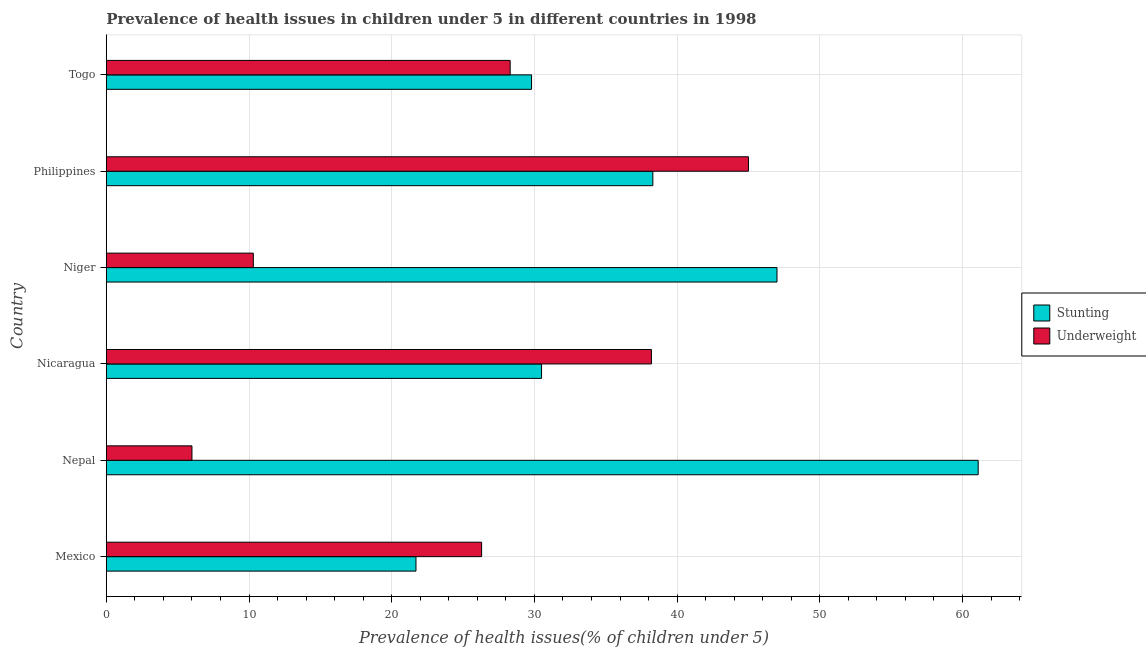How many different coloured bars are there?
Keep it short and to the point. 2. How many groups of bars are there?
Offer a terse response. 6. Are the number of bars per tick equal to the number of legend labels?
Offer a terse response. Yes. Are the number of bars on each tick of the Y-axis equal?
Offer a very short reply. Yes. How many bars are there on the 1st tick from the bottom?
Your response must be concise. 2. What is the percentage of underweight children in Nepal?
Ensure brevity in your answer.  6. Across all countries, what is the maximum percentage of underweight children?
Offer a very short reply. 45. Across all countries, what is the minimum percentage of underweight children?
Your response must be concise. 6. In which country was the percentage of stunted children maximum?
Give a very brief answer. Nepal. What is the total percentage of stunted children in the graph?
Your answer should be compact. 228.4. What is the difference between the percentage of stunted children in Niger and the percentage of underweight children in Nepal?
Give a very brief answer. 41. What is the average percentage of stunted children per country?
Provide a succinct answer. 38.07. What is the difference between the percentage of stunted children and percentage of underweight children in Mexico?
Keep it short and to the point. -4.6. In how many countries, is the percentage of underweight children greater than 32 %?
Offer a very short reply. 2. What is the ratio of the percentage of underweight children in Mexico to that in Philippines?
Your answer should be very brief. 0.58. Is the difference between the percentage of underweight children in Nicaragua and Philippines greater than the difference between the percentage of stunted children in Nicaragua and Philippines?
Offer a terse response. Yes. What is the difference between the highest and the lowest percentage of stunted children?
Keep it short and to the point. 39.4. In how many countries, is the percentage of stunted children greater than the average percentage of stunted children taken over all countries?
Give a very brief answer. 3. Is the sum of the percentage of underweight children in Nepal and Philippines greater than the maximum percentage of stunted children across all countries?
Make the answer very short. No. What does the 1st bar from the top in Togo represents?
Your answer should be compact. Underweight. What does the 1st bar from the bottom in Togo represents?
Provide a short and direct response. Stunting. How many countries are there in the graph?
Ensure brevity in your answer.  6. What is the difference between two consecutive major ticks on the X-axis?
Offer a terse response. 10. Are the values on the major ticks of X-axis written in scientific E-notation?
Give a very brief answer. No. Does the graph contain grids?
Offer a very short reply. Yes. Where does the legend appear in the graph?
Give a very brief answer. Center right. How are the legend labels stacked?
Your answer should be compact. Vertical. What is the title of the graph?
Make the answer very short. Prevalence of health issues in children under 5 in different countries in 1998. What is the label or title of the X-axis?
Ensure brevity in your answer.  Prevalence of health issues(% of children under 5). What is the Prevalence of health issues(% of children under 5) of Stunting in Mexico?
Your answer should be very brief. 21.7. What is the Prevalence of health issues(% of children under 5) of Underweight in Mexico?
Your answer should be compact. 26.3. What is the Prevalence of health issues(% of children under 5) of Stunting in Nepal?
Keep it short and to the point. 61.1. What is the Prevalence of health issues(% of children under 5) in Stunting in Nicaragua?
Your answer should be compact. 30.5. What is the Prevalence of health issues(% of children under 5) in Underweight in Nicaragua?
Offer a terse response. 38.2. What is the Prevalence of health issues(% of children under 5) in Stunting in Niger?
Give a very brief answer. 47. What is the Prevalence of health issues(% of children under 5) of Underweight in Niger?
Offer a terse response. 10.3. What is the Prevalence of health issues(% of children under 5) in Stunting in Philippines?
Your answer should be compact. 38.3. What is the Prevalence of health issues(% of children under 5) of Underweight in Philippines?
Offer a terse response. 45. What is the Prevalence of health issues(% of children under 5) in Stunting in Togo?
Your answer should be very brief. 29.8. What is the Prevalence of health issues(% of children under 5) in Underweight in Togo?
Keep it short and to the point. 28.3. Across all countries, what is the maximum Prevalence of health issues(% of children under 5) of Stunting?
Your response must be concise. 61.1. Across all countries, what is the maximum Prevalence of health issues(% of children under 5) in Underweight?
Give a very brief answer. 45. Across all countries, what is the minimum Prevalence of health issues(% of children under 5) in Stunting?
Your answer should be compact. 21.7. What is the total Prevalence of health issues(% of children under 5) of Stunting in the graph?
Ensure brevity in your answer.  228.4. What is the total Prevalence of health issues(% of children under 5) in Underweight in the graph?
Ensure brevity in your answer.  154.1. What is the difference between the Prevalence of health issues(% of children under 5) of Stunting in Mexico and that in Nepal?
Offer a very short reply. -39.4. What is the difference between the Prevalence of health issues(% of children under 5) in Underweight in Mexico and that in Nepal?
Offer a terse response. 20.3. What is the difference between the Prevalence of health issues(% of children under 5) of Stunting in Mexico and that in Niger?
Ensure brevity in your answer.  -25.3. What is the difference between the Prevalence of health issues(% of children under 5) of Stunting in Mexico and that in Philippines?
Keep it short and to the point. -16.6. What is the difference between the Prevalence of health issues(% of children under 5) in Underweight in Mexico and that in Philippines?
Offer a very short reply. -18.7. What is the difference between the Prevalence of health issues(% of children under 5) of Underweight in Mexico and that in Togo?
Your response must be concise. -2. What is the difference between the Prevalence of health issues(% of children under 5) in Stunting in Nepal and that in Nicaragua?
Provide a short and direct response. 30.6. What is the difference between the Prevalence of health issues(% of children under 5) in Underweight in Nepal and that in Nicaragua?
Ensure brevity in your answer.  -32.2. What is the difference between the Prevalence of health issues(% of children under 5) of Stunting in Nepal and that in Niger?
Offer a terse response. 14.1. What is the difference between the Prevalence of health issues(% of children under 5) in Underweight in Nepal and that in Niger?
Provide a succinct answer. -4.3. What is the difference between the Prevalence of health issues(% of children under 5) in Stunting in Nepal and that in Philippines?
Offer a very short reply. 22.8. What is the difference between the Prevalence of health issues(% of children under 5) in Underweight in Nepal and that in Philippines?
Provide a succinct answer. -39. What is the difference between the Prevalence of health issues(% of children under 5) of Stunting in Nepal and that in Togo?
Your answer should be very brief. 31.3. What is the difference between the Prevalence of health issues(% of children under 5) of Underweight in Nepal and that in Togo?
Your response must be concise. -22.3. What is the difference between the Prevalence of health issues(% of children under 5) of Stunting in Nicaragua and that in Niger?
Your answer should be compact. -16.5. What is the difference between the Prevalence of health issues(% of children under 5) of Underweight in Nicaragua and that in Niger?
Keep it short and to the point. 27.9. What is the difference between the Prevalence of health issues(% of children under 5) in Underweight in Nicaragua and that in Philippines?
Make the answer very short. -6.8. What is the difference between the Prevalence of health issues(% of children under 5) of Stunting in Nicaragua and that in Togo?
Your answer should be very brief. 0.7. What is the difference between the Prevalence of health issues(% of children under 5) of Underweight in Niger and that in Philippines?
Offer a very short reply. -34.7. What is the difference between the Prevalence of health issues(% of children under 5) in Stunting in Niger and that in Togo?
Offer a very short reply. 17.2. What is the difference between the Prevalence of health issues(% of children under 5) in Underweight in Philippines and that in Togo?
Your answer should be very brief. 16.7. What is the difference between the Prevalence of health issues(% of children under 5) of Stunting in Mexico and the Prevalence of health issues(% of children under 5) of Underweight in Nepal?
Your answer should be very brief. 15.7. What is the difference between the Prevalence of health issues(% of children under 5) in Stunting in Mexico and the Prevalence of health issues(% of children under 5) in Underweight in Nicaragua?
Make the answer very short. -16.5. What is the difference between the Prevalence of health issues(% of children under 5) in Stunting in Mexico and the Prevalence of health issues(% of children under 5) in Underweight in Niger?
Provide a short and direct response. 11.4. What is the difference between the Prevalence of health issues(% of children under 5) of Stunting in Mexico and the Prevalence of health issues(% of children under 5) of Underweight in Philippines?
Ensure brevity in your answer.  -23.3. What is the difference between the Prevalence of health issues(% of children under 5) of Stunting in Mexico and the Prevalence of health issues(% of children under 5) of Underweight in Togo?
Ensure brevity in your answer.  -6.6. What is the difference between the Prevalence of health issues(% of children under 5) in Stunting in Nepal and the Prevalence of health issues(% of children under 5) in Underweight in Nicaragua?
Your answer should be very brief. 22.9. What is the difference between the Prevalence of health issues(% of children under 5) of Stunting in Nepal and the Prevalence of health issues(% of children under 5) of Underweight in Niger?
Offer a very short reply. 50.8. What is the difference between the Prevalence of health issues(% of children under 5) of Stunting in Nepal and the Prevalence of health issues(% of children under 5) of Underweight in Togo?
Keep it short and to the point. 32.8. What is the difference between the Prevalence of health issues(% of children under 5) of Stunting in Nicaragua and the Prevalence of health issues(% of children under 5) of Underweight in Niger?
Provide a succinct answer. 20.2. What is the average Prevalence of health issues(% of children under 5) of Stunting per country?
Keep it short and to the point. 38.07. What is the average Prevalence of health issues(% of children under 5) in Underweight per country?
Offer a terse response. 25.68. What is the difference between the Prevalence of health issues(% of children under 5) of Stunting and Prevalence of health issues(% of children under 5) of Underweight in Mexico?
Provide a succinct answer. -4.6. What is the difference between the Prevalence of health issues(% of children under 5) in Stunting and Prevalence of health issues(% of children under 5) in Underweight in Nepal?
Offer a very short reply. 55.1. What is the difference between the Prevalence of health issues(% of children under 5) of Stunting and Prevalence of health issues(% of children under 5) of Underweight in Niger?
Keep it short and to the point. 36.7. What is the difference between the Prevalence of health issues(% of children under 5) in Stunting and Prevalence of health issues(% of children under 5) in Underweight in Philippines?
Your answer should be very brief. -6.7. What is the difference between the Prevalence of health issues(% of children under 5) of Stunting and Prevalence of health issues(% of children under 5) of Underweight in Togo?
Give a very brief answer. 1.5. What is the ratio of the Prevalence of health issues(% of children under 5) in Stunting in Mexico to that in Nepal?
Ensure brevity in your answer.  0.36. What is the ratio of the Prevalence of health issues(% of children under 5) in Underweight in Mexico to that in Nepal?
Your answer should be compact. 4.38. What is the ratio of the Prevalence of health issues(% of children under 5) of Stunting in Mexico to that in Nicaragua?
Provide a succinct answer. 0.71. What is the ratio of the Prevalence of health issues(% of children under 5) of Underweight in Mexico to that in Nicaragua?
Ensure brevity in your answer.  0.69. What is the ratio of the Prevalence of health issues(% of children under 5) in Stunting in Mexico to that in Niger?
Your response must be concise. 0.46. What is the ratio of the Prevalence of health issues(% of children under 5) in Underweight in Mexico to that in Niger?
Provide a short and direct response. 2.55. What is the ratio of the Prevalence of health issues(% of children under 5) in Stunting in Mexico to that in Philippines?
Your answer should be very brief. 0.57. What is the ratio of the Prevalence of health issues(% of children under 5) of Underweight in Mexico to that in Philippines?
Keep it short and to the point. 0.58. What is the ratio of the Prevalence of health issues(% of children under 5) in Stunting in Mexico to that in Togo?
Provide a short and direct response. 0.73. What is the ratio of the Prevalence of health issues(% of children under 5) of Underweight in Mexico to that in Togo?
Your answer should be compact. 0.93. What is the ratio of the Prevalence of health issues(% of children under 5) in Stunting in Nepal to that in Nicaragua?
Make the answer very short. 2. What is the ratio of the Prevalence of health issues(% of children under 5) in Underweight in Nepal to that in Nicaragua?
Provide a succinct answer. 0.16. What is the ratio of the Prevalence of health issues(% of children under 5) in Stunting in Nepal to that in Niger?
Provide a short and direct response. 1.3. What is the ratio of the Prevalence of health issues(% of children under 5) of Underweight in Nepal to that in Niger?
Your answer should be very brief. 0.58. What is the ratio of the Prevalence of health issues(% of children under 5) of Stunting in Nepal to that in Philippines?
Keep it short and to the point. 1.6. What is the ratio of the Prevalence of health issues(% of children under 5) in Underweight in Nepal to that in Philippines?
Ensure brevity in your answer.  0.13. What is the ratio of the Prevalence of health issues(% of children under 5) in Stunting in Nepal to that in Togo?
Make the answer very short. 2.05. What is the ratio of the Prevalence of health issues(% of children under 5) in Underweight in Nepal to that in Togo?
Give a very brief answer. 0.21. What is the ratio of the Prevalence of health issues(% of children under 5) of Stunting in Nicaragua to that in Niger?
Offer a terse response. 0.65. What is the ratio of the Prevalence of health issues(% of children under 5) of Underweight in Nicaragua to that in Niger?
Ensure brevity in your answer.  3.71. What is the ratio of the Prevalence of health issues(% of children under 5) in Stunting in Nicaragua to that in Philippines?
Make the answer very short. 0.8. What is the ratio of the Prevalence of health issues(% of children under 5) of Underweight in Nicaragua to that in Philippines?
Offer a terse response. 0.85. What is the ratio of the Prevalence of health issues(% of children under 5) of Stunting in Nicaragua to that in Togo?
Offer a terse response. 1.02. What is the ratio of the Prevalence of health issues(% of children under 5) of Underweight in Nicaragua to that in Togo?
Ensure brevity in your answer.  1.35. What is the ratio of the Prevalence of health issues(% of children under 5) of Stunting in Niger to that in Philippines?
Your answer should be compact. 1.23. What is the ratio of the Prevalence of health issues(% of children under 5) in Underweight in Niger to that in Philippines?
Provide a succinct answer. 0.23. What is the ratio of the Prevalence of health issues(% of children under 5) in Stunting in Niger to that in Togo?
Your response must be concise. 1.58. What is the ratio of the Prevalence of health issues(% of children under 5) in Underweight in Niger to that in Togo?
Your answer should be very brief. 0.36. What is the ratio of the Prevalence of health issues(% of children under 5) of Stunting in Philippines to that in Togo?
Your answer should be compact. 1.29. What is the ratio of the Prevalence of health issues(% of children under 5) in Underweight in Philippines to that in Togo?
Give a very brief answer. 1.59. What is the difference between the highest and the second highest Prevalence of health issues(% of children under 5) in Stunting?
Offer a very short reply. 14.1. What is the difference between the highest and the second highest Prevalence of health issues(% of children under 5) of Underweight?
Offer a very short reply. 6.8. What is the difference between the highest and the lowest Prevalence of health issues(% of children under 5) in Stunting?
Ensure brevity in your answer.  39.4. What is the difference between the highest and the lowest Prevalence of health issues(% of children under 5) of Underweight?
Provide a short and direct response. 39. 